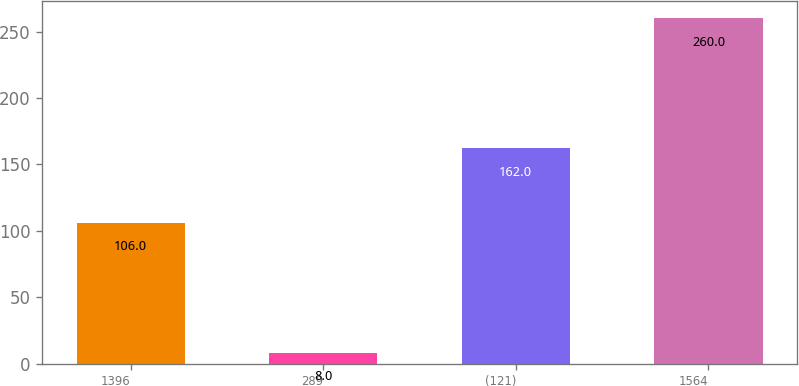<chart> <loc_0><loc_0><loc_500><loc_500><bar_chart><fcel>1396<fcel>289<fcel>(121)<fcel>1564<nl><fcel>106<fcel>8<fcel>162<fcel>260<nl></chart> 